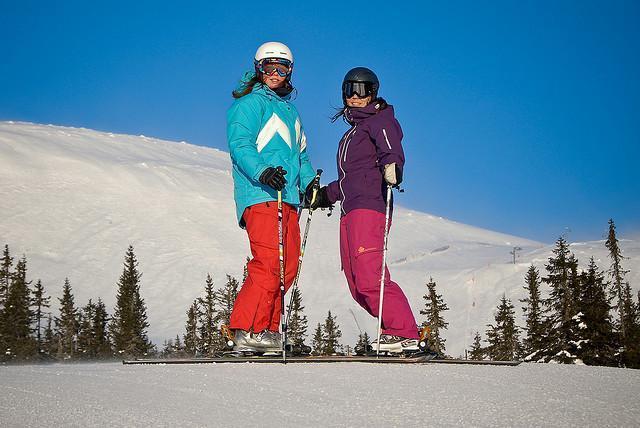How many people are in the photo?
Give a very brief answer. 2. How many people can be seen?
Give a very brief answer. 2. How many glasses are full of orange juice?
Give a very brief answer. 0. 